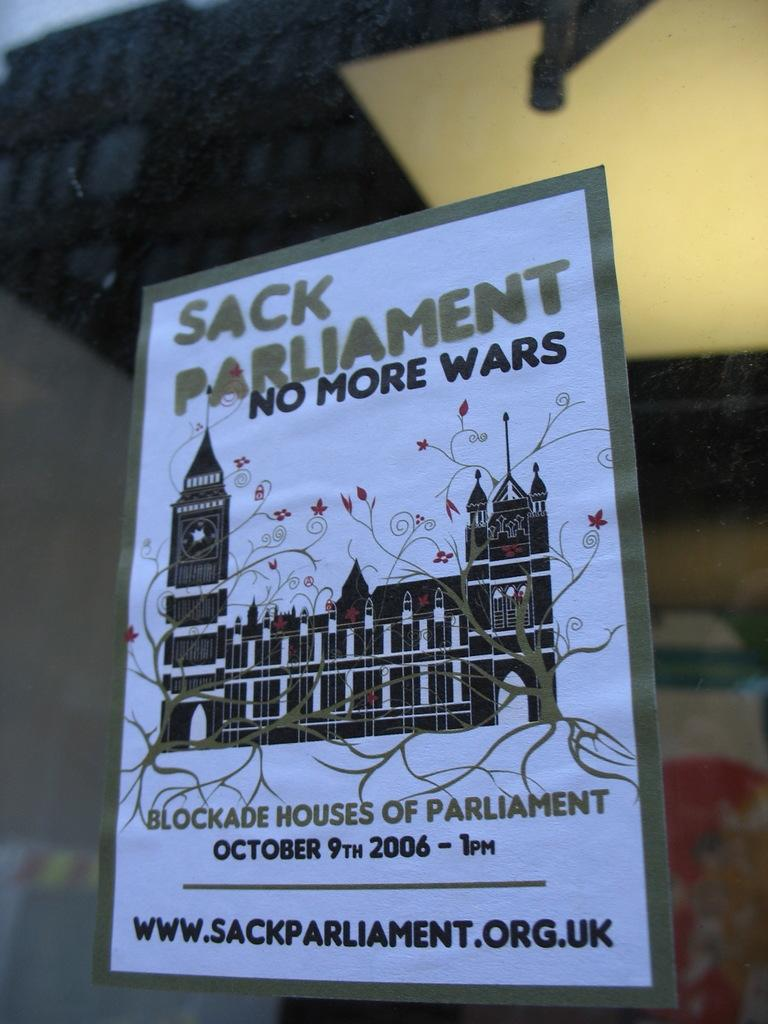Provide a one-sentence caption for the provided image. A poster showing a event in which they want to Sack Parliament due to wars. 